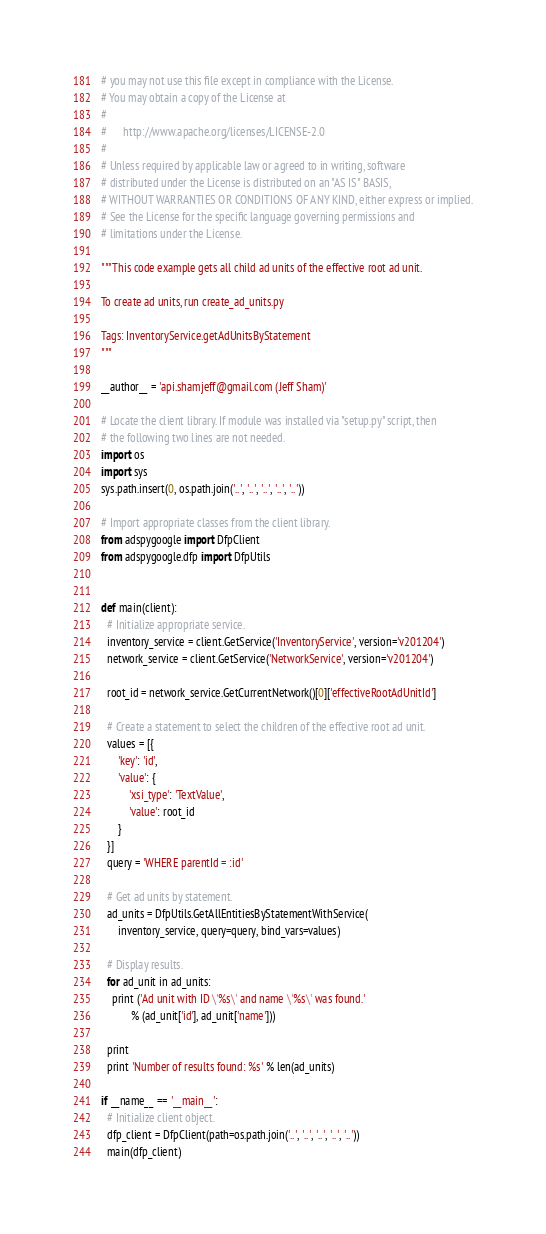Convert code to text. <code><loc_0><loc_0><loc_500><loc_500><_Python_># you may not use this file except in compliance with the License.
# You may obtain a copy of the License at
#
#      http://www.apache.org/licenses/LICENSE-2.0
#
# Unless required by applicable law or agreed to in writing, software
# distributed under the License is distributed on an "AS IS" BASIS,
# WITHOUT WARRANTIES OR CONDITIONS OF ANY KIND, either express or implied.
# See the License for the specific language governing permissions and
# limitations under the License.

"""This code example gets all child ad units of the effective root ad unit.

To create ad units, run create_ad_units.py

Tags: InventoryService.getAdUnitsByStatement
"""

__author__ = 'api.shamjeff@gmail.com (Jeff Sham)'

# Locate the client library. If module was installed via "setup.py" script, then
# the following two lines are not needed.
import os
import sys
sys.path.insert(0, os.path.join('..', '..', '..', '..', '..'))

# Import appropriate classes from the client library.
from adspygoogle import DfpClient
from adspygoogle.dfp import DfpUtils


def main(client):
  # Initialize appropriate service.
  inventory_service = client.GetService('InventoryService', version='v201204')
  network_service = client.GetService('NetworkService', version='v201204')

  root_id = network_service.GetCurrentNetwork()[0]['effectiveRootAdUnitId']

  # Create a statement to select the children of the effective root ad unit.
  values = [{
      'key': 'id',
      'value': {
          'xsi_type': 'TextValue',
          'value': root_id
      }
  }]
  query = 'WHERE parentId = :id'

  # Get ad units by statement.
  ad_units = DfpUtils.GetAllEntitiesByStatementWithService(
      inventory_service, query=query, bind_vars=values)

  # Display results.
  for ad_unit in ad_units:
    print ('Ad unit with ID \'%s\' and name \'%s\' was found.'
           % (ad_unit['id'], ad_unit['name']))

  print
  print 'Number of results found: %s' % len(ad_units)

if __name__ == '__main__':
  # Initialize client object.
  dfp_client = DfpClient(path=os.path.join('..', '..', '..', '..', '..'))
  main(dfp_client)
</code> 